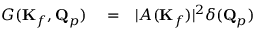Convert formula to latex. <formula><loc_0><loc_0><loc_500><loc_500>\begin{array} { r l r } { G ( K _ { f } , Q _ { p } ) } & = } & { | A ( K _ { f } ) | ^ { 2 } \delta ( Q _ { p } ) } \end{array}</formula> 